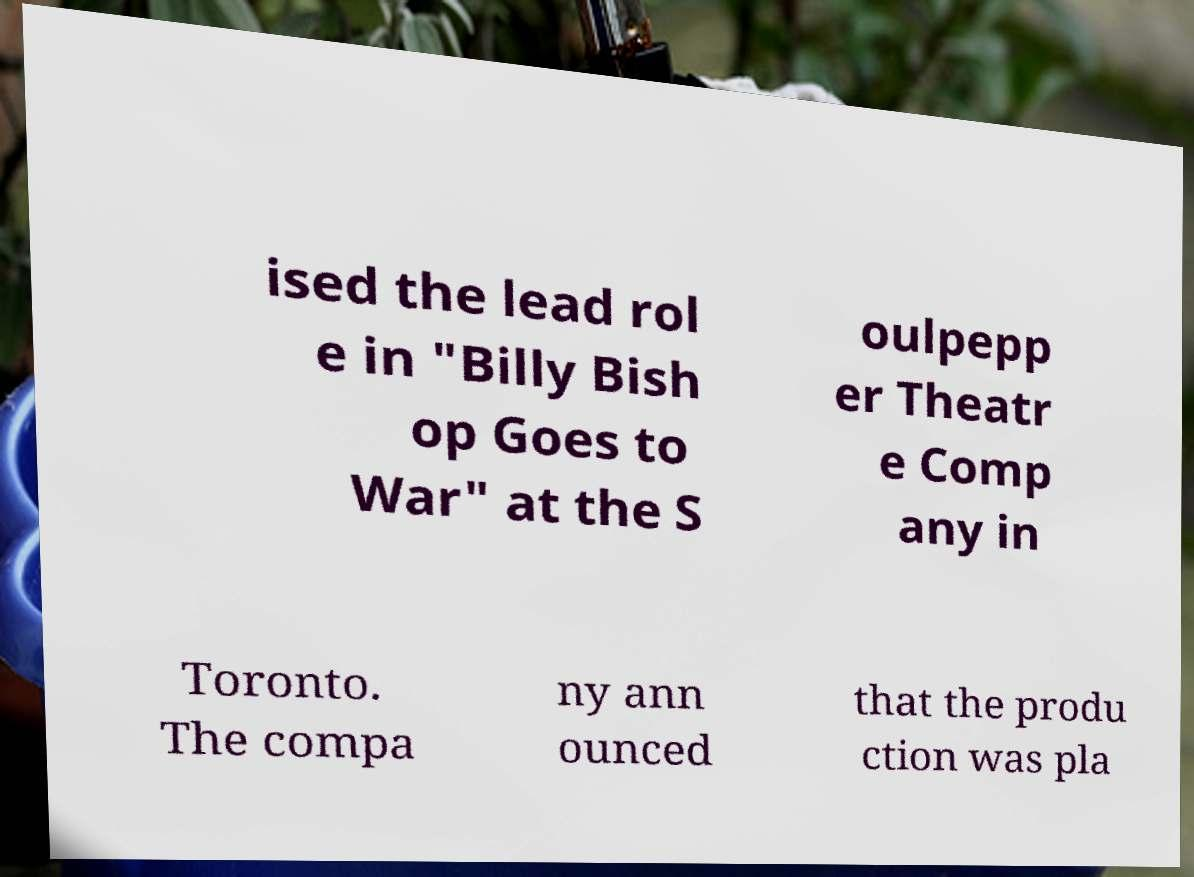Can you accurately transcribe the text from the provided image for me? ised the lead rol e in "Billy Bish op Goes to War" at the S oulpepp er Theatr e Comp any in Toronto. The compa ny ann ounced that the produ ction was pla 